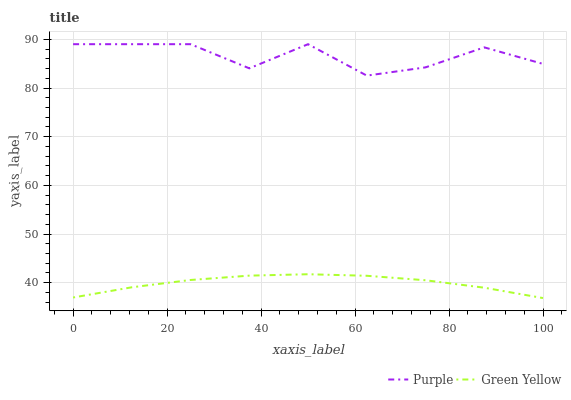Does Green Yellow have the minimum area under the curve?
Answer yes or no. Yes. Does Purple have the maximum area under the curve?
Answer yes or no. Yes. Does Green Yellow have the maximum area under the curve?
Answer yes or no. No. Is Green Yellow the smoothest?
Answer yes or no. Yes. Is Purple the roughest?
Answer yes or no. Yes. Is Green Yellow the roughest?
Answer yes or no. No. Does Purple have the highest value?
Answer yes or no. Yes. Does Green Yellow have the highest value?
Answer yes or no. No. Is Green Yellow less than Purple?
Answer yes or no. Yes. Is Purple greater than Green Yellow?
Answer yes or no. Yes. Does Green Yellow intersect Purple?
Answer yes or no. No. 